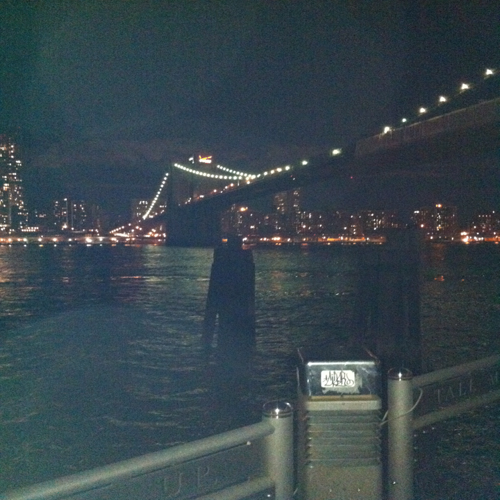What is the overall sharpness of this image? The overall sharpness of the image can be considered moderately high, as the details on the bridge and its lights are quite distinct. However, the edges are not crisp, suggesting that while the sharpness isn't perfect, it's sufficient to make out the main subjects of the photo clearly. 